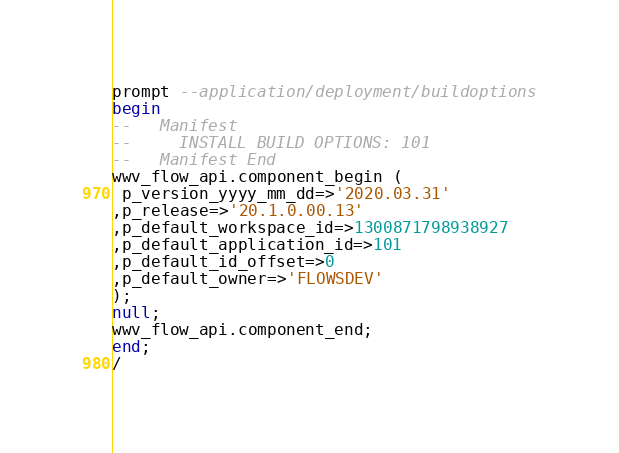<code> <loc_0><loc_0><loc_500><loc_500><_SQL_>prompt --application/deployment/buildoptions
begin
--   Manifest
--     INSTALL BUILD OPTIONS: 101
--   Manifest End
wwv_flow_api.component_begin (
 p_version_yyyy_mm_dd=>'2020.03.31'
,p_release=>'20.1.0.00.13'
,p_default_workspace_id=>1300871798938927
,p_default_application_id=>101
,p_default_id_offset=>0
,p_default_owner=>'FLOWSDEV'
);
null;
wwv_flow_api.component_end;
end;
/
</code> 